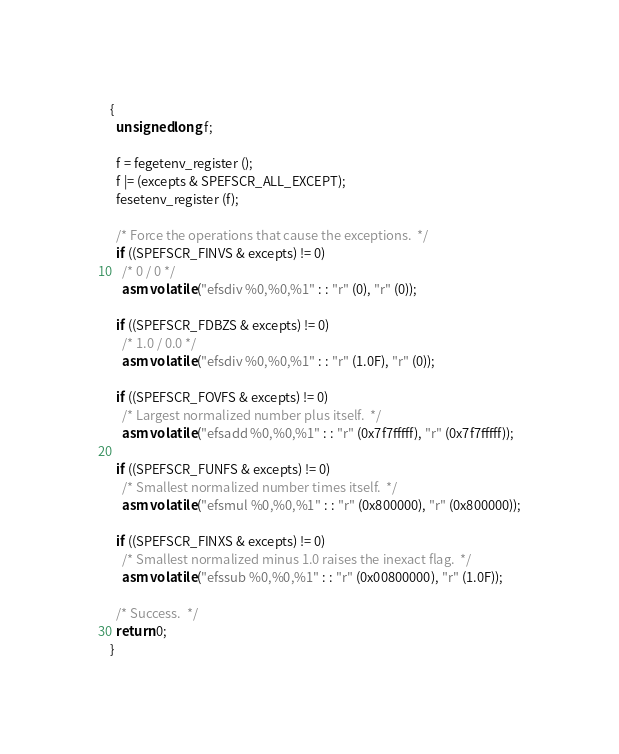Convert code to text. <code><loc_0><loc_0><loc_500><loc_500><_C_>{
  unsigned long f;

  f = fegetenv_register ();
  f |= (excepts & SPEFSCR_ALL_EXCEPT);
  fesetenv_register (f);

  /* Force the operations that cause the exceptions.  */
  if ((SPEFSCR_FINVS & excepts) != 0)
    /* 0 / 0 */
    asm volatile ("efsdiv %0,%0,%1" : : "r" (0), "r" (0));

  if ((SPEFSCR_FDBZS & excepts) != 0)
    /* 1.0 / 0.0 */
    asm volatile ("efsdiv %0,%0,%1" : : "r" (1.0F), "r" (0));

  if ((SPEFSCR_FOVFS & excepts) != 0)
    /* Largest normalized number plus itself.  */
    asm volatile ("efsadd %0,%0,%1" : : "r" (0x7f7fffff), "r" (0x7f7fffff));

  if ((SPEFSCR_FUNFS & excepts) != 0)
    /* Smallest normalized number times itself.  */
    asm volatile ("efsmul %0,%0,%1" : : "r" (0x800000), "r" (0x800000));

  if ((SPEFSCR_FINXS & excepts) != 0)
    /* Smallest normalized minus 1.0 raises the inexact flag.  */
    asm volatile ("efssub %0,%0,%1" : : "r" (0x00800000), "r" (1.0F));

  /* Success.  */
  return 0;
}
</code> 